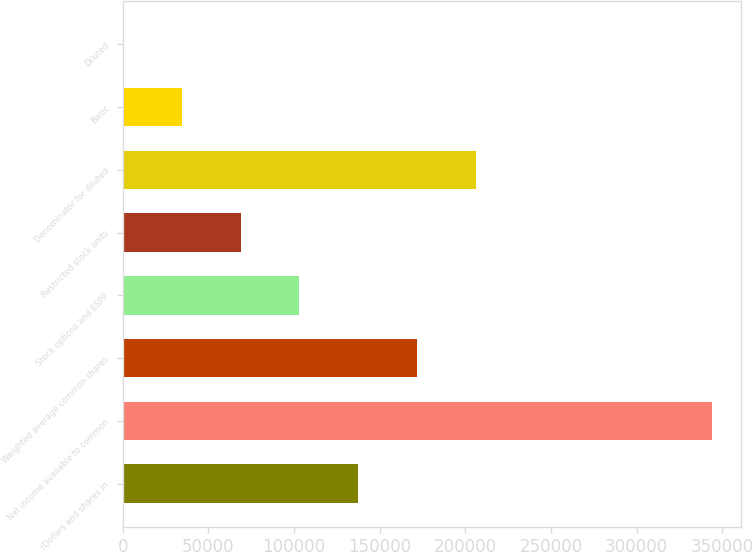Convert chart to OTSL. <chart><loc_0><loc_0><loc_500><loc_500><bar_chart><fcel>(Dollars and shares in<fcel>Net income available to common<fcel>Weighted average common shares<fcel>Stock options and ESPP<fcel>Restricted stock units<fcel>Denominator for diluted<fcel>Basic<fcel>Diluted<nl><fcel>137566<fcel>343904<fcel>171955<fcel>103176<fcel>68786.1<fcel>206345<fcel>34396.4<fcel>6.62<nl></chart> 